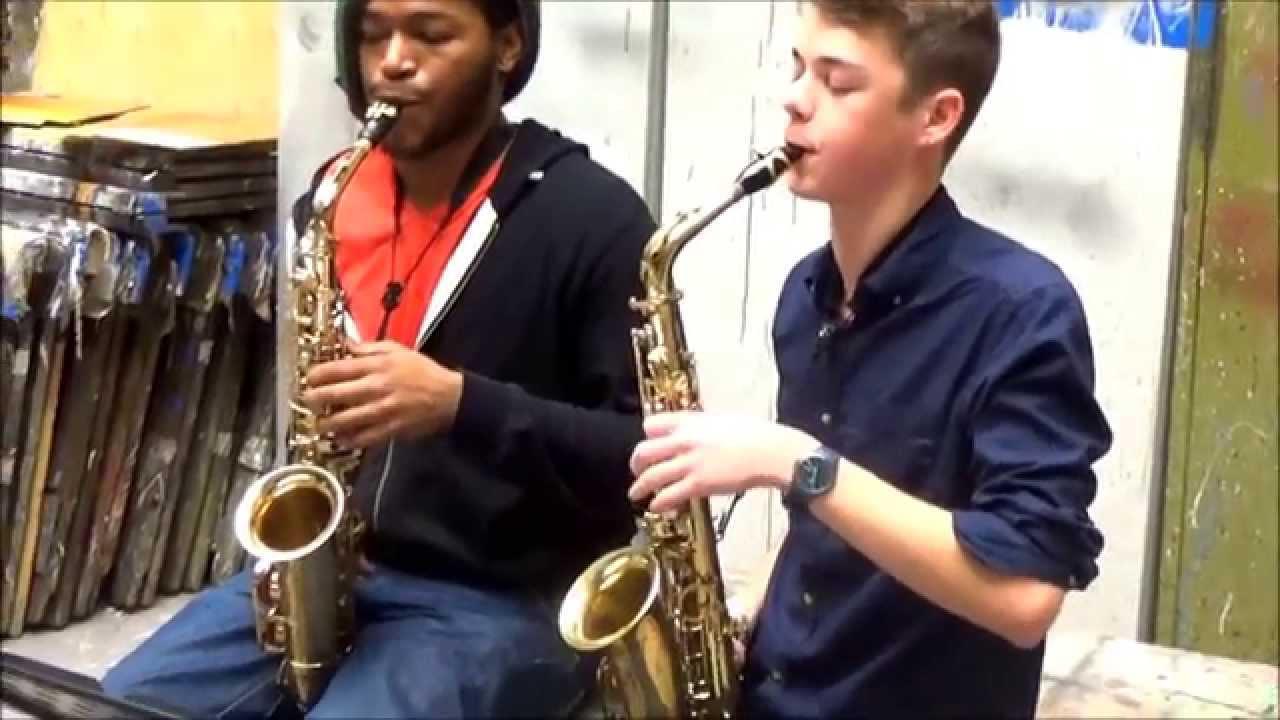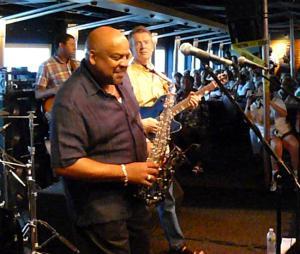The first image is the image on the left, the second image is the image on the right. Analyze the images presented: Is the assertion "A man is holding two saxophones in the image on the left." valid? Answer yes or no. No. The first image is the image on the left, the second image is the image on the right. For the images displayed, is the sentence "there is a bald ban holding an instrument with a bracelet  on and a short sleeved button down shirt" factually correct? Answer yes or no. Yes. 